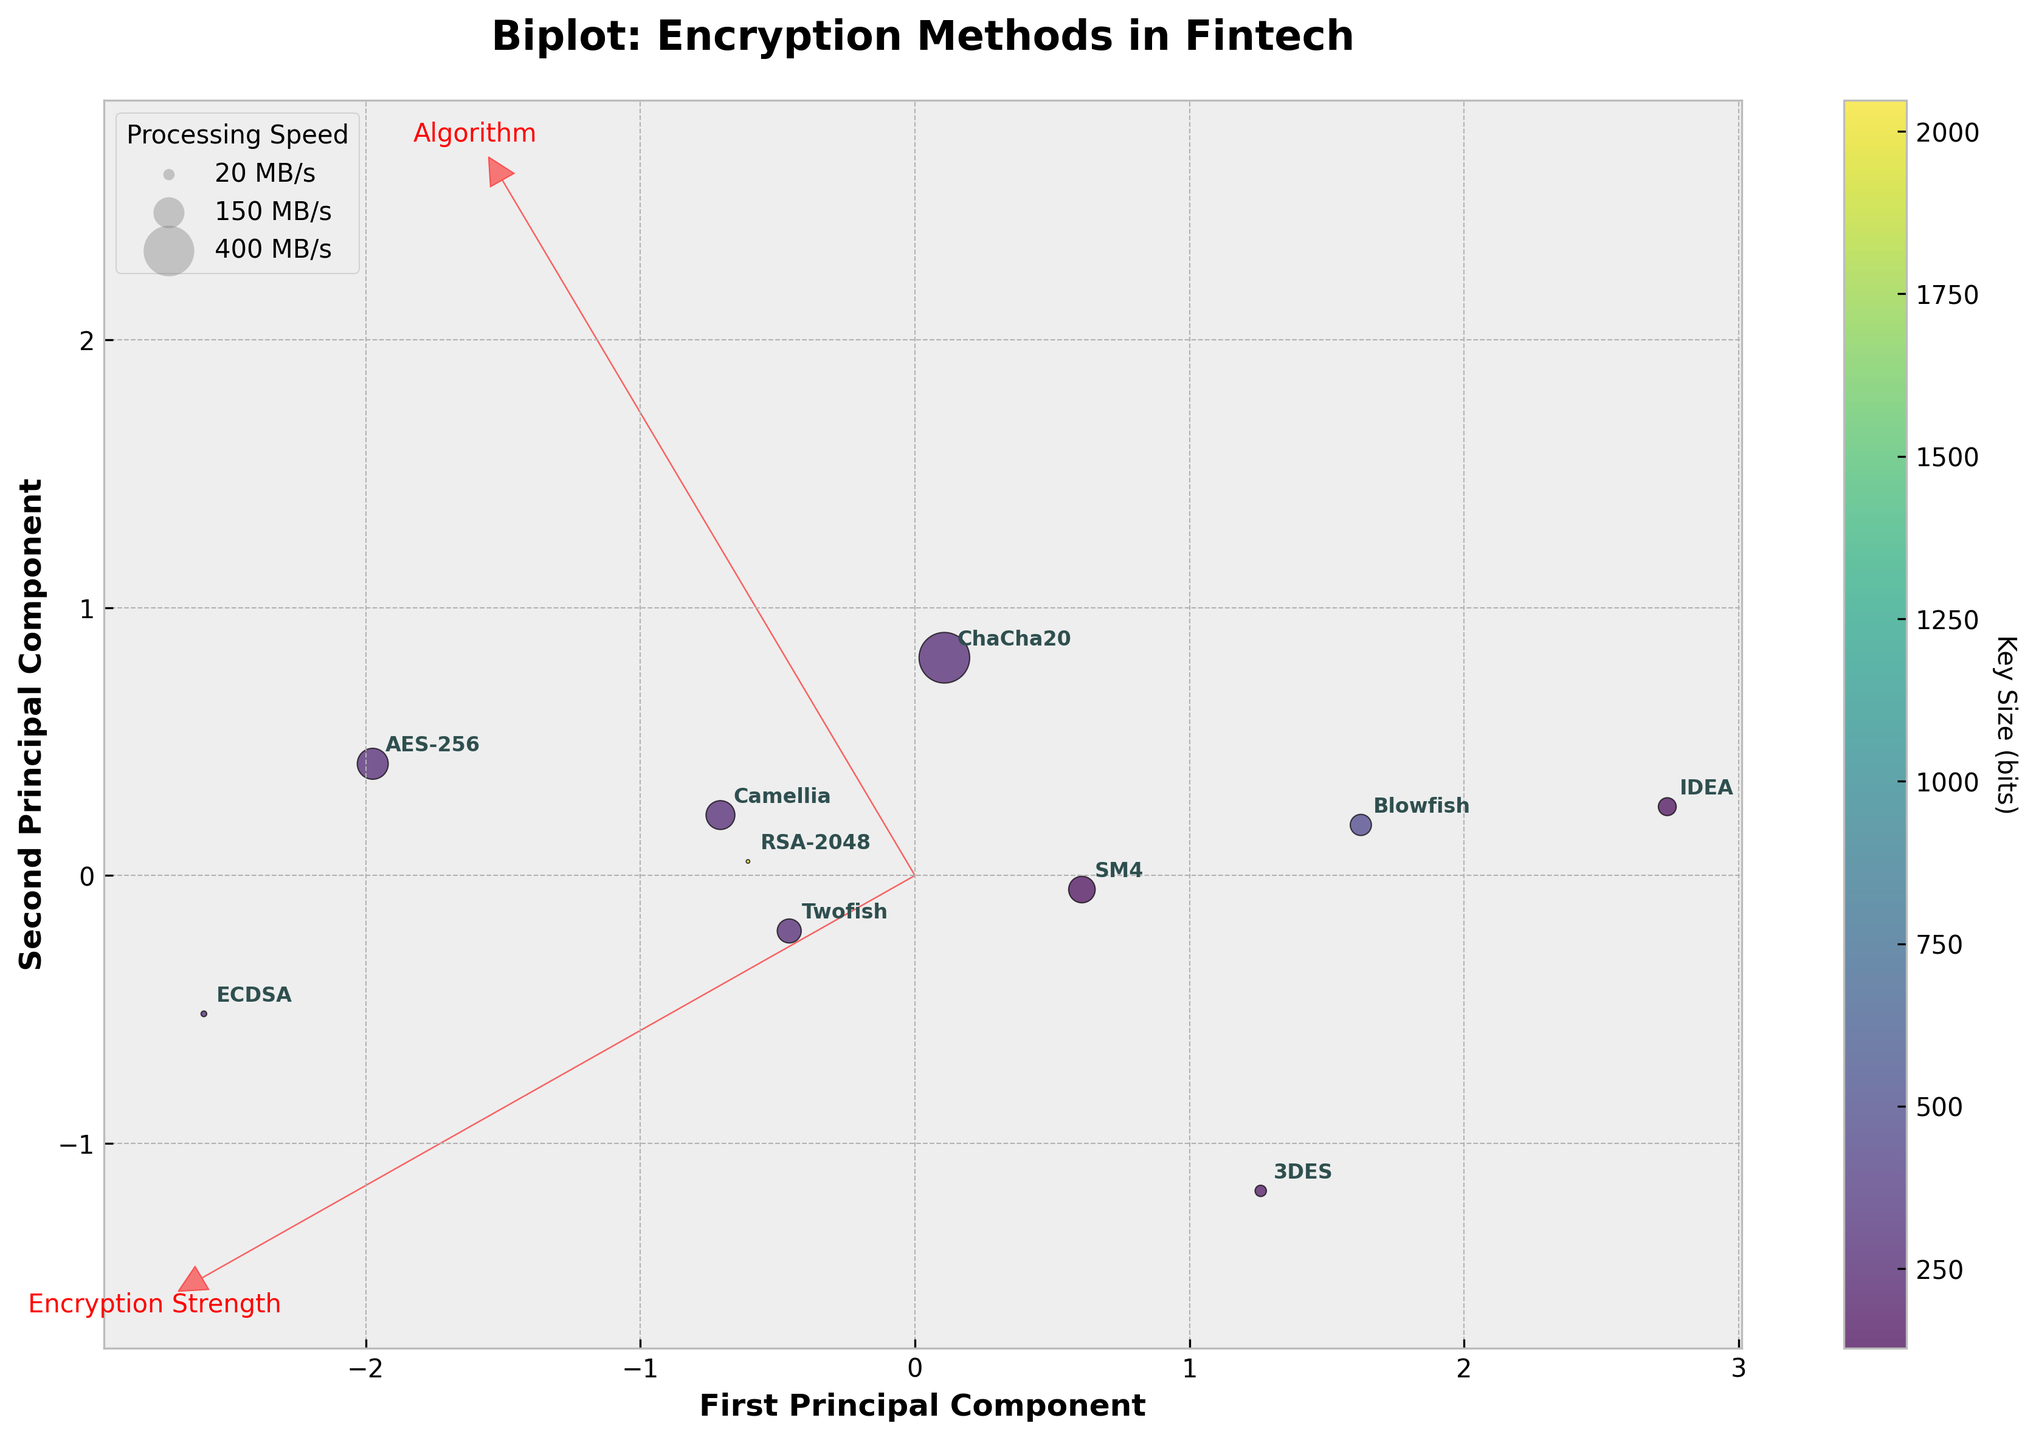What is the title of the plot? The title is usually found at the top of the plot and describes what the plot is about.
Answer: Biplot: Encryption Methods in Fintech How many encryption algorithms are compared in the plot? Count the number of distinct points or labels representing different algorithms.
Answer: 10 Which algorithm has the highest processing speed? Locate the point with the largest bubble size, as bubble size represents processing speed (MB/s).
Answer: ChaCha20 Which algorithm has the highest implementation cost? Find the point that is most aligned with the positive direction of the implementation cost vector (second principal component direction).
Answer: ECDSA Between AES-256 and RSA-2048, which algorithm has higher encryption strength? Compare their positions along the first principal component direction, which correlates with encryption strength.
Answer: AES-256 What are the two main features depicted by the arrows in the biplot? Identify the labels at the end of the feature arrows, as they represent the principal components.
Answer: Encryption Strength and Implementation Cost Which algorithms are more optimized for low implementation costs and high processing speeds? Look for algorithms positioned in the lower-left quadrant of the plot, indicating low cost and high speed.
Answer: ChaCha20 and Blowfish Between 3DES and IDEA, which one has higher encryption strength, and which one has a lower implementation cost? Compare their positions relative to each principal component: the first component for encryption strength and the second for implementation cost.
Answer: 3DES has higher encryption strength, IDEA has a lower implementation cost How does the key size affect the placement of encryption algorithms in the biplot? Observe the color gradients representing key sizes and their correlation with the plot coordinates. Generally, there should be no direct correlation since the key size is not a principal component.
Answer: There is no direct correlation What are the axes labeled in the biplot? Read the labels on the x-axis and the y-axis.
Answer: First Principal Component and Second Principal Component 